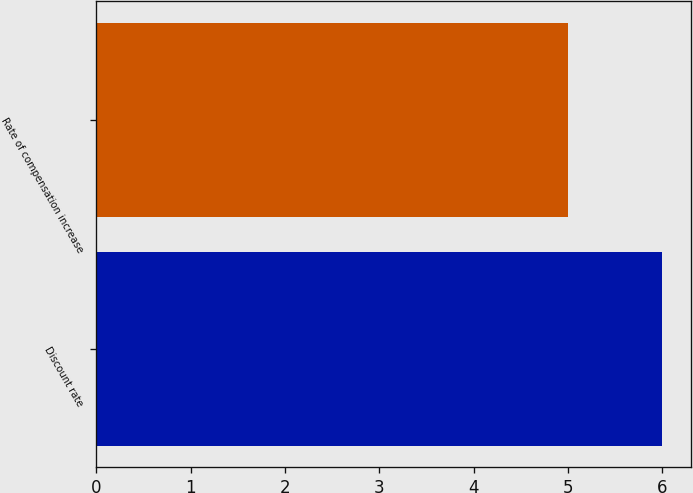Convert chart to OTSL. <chart><loc_0><loc_0><loc_500><loc_500><bar_chart><fcel>Discount rate<fcel>Rate of compensation increase<nl><fcel>6<fcel>5<nl></chart> 